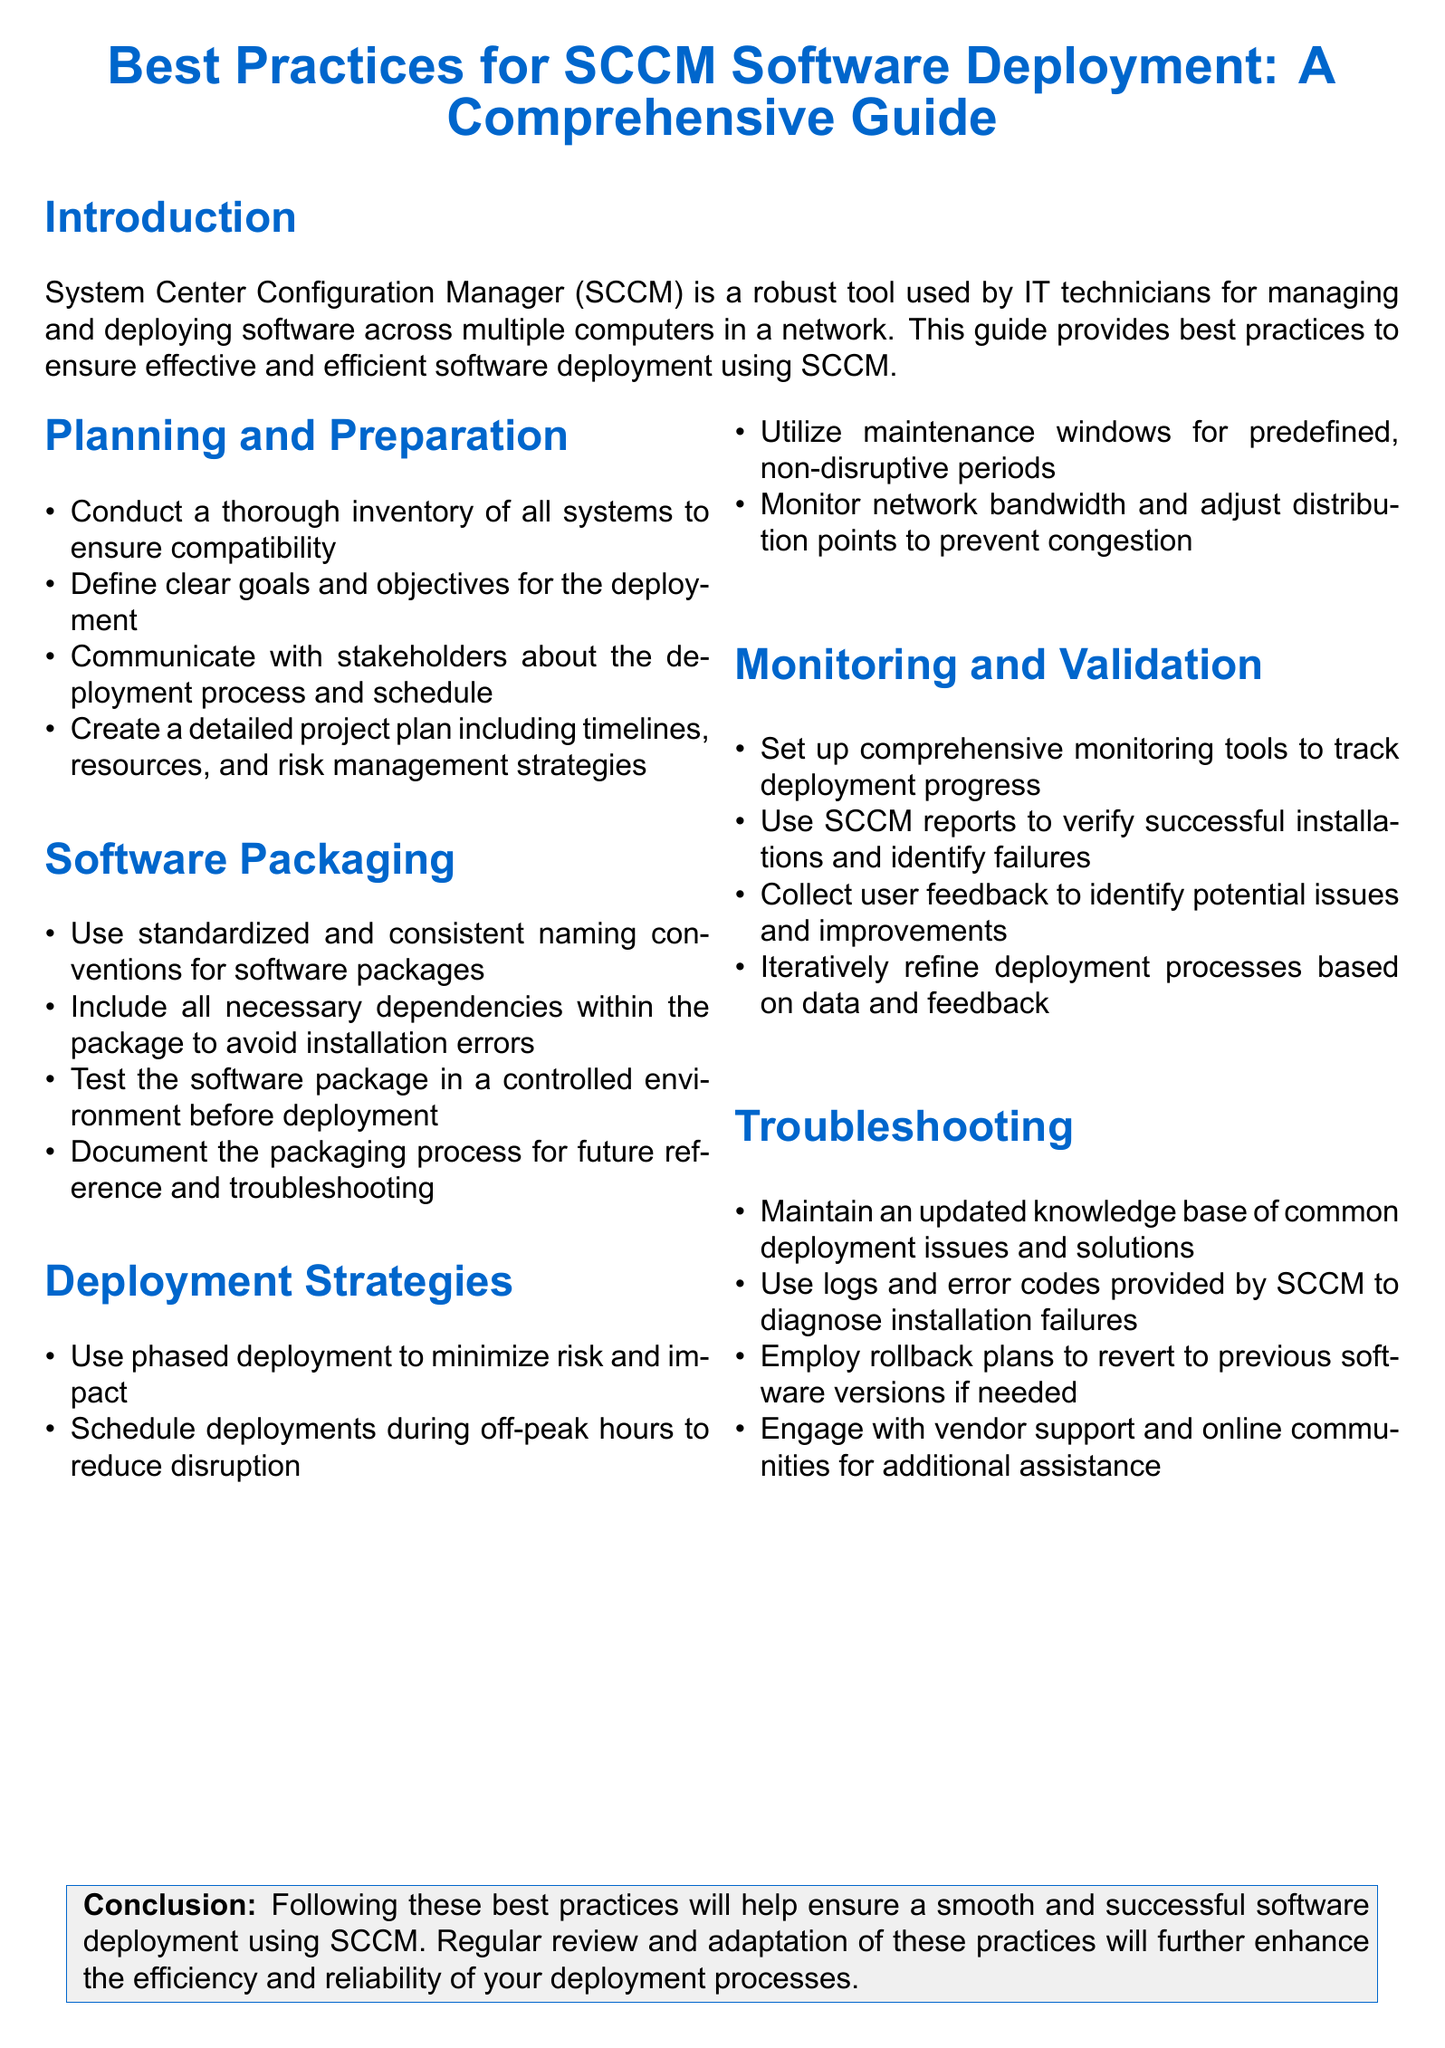What is the primary tool discussed in the document? The document discusses System Center Configuration Manager (SCCM) as the primary tool for software management and deployment.
Answer: System Center Configuration Manager (SCCM) What should be included in a project plan for software deployment? The project plan should include timelines, resources, and risk management strategies as part of its details.
Answer: Timelines, resources, and risk management strategies What is a recommended time for scheduling deployments? The document suggests scheduling deployments during off-peak hours to minimize disruption.
Answer: Off-peak hours How many sections are there in the document? The document has five sections, including Planning and Preparation, Software Packaging, Deployment Strategies, Monitoring and Validation, and Troubleshooting.
Answer: Five What is a benefit of using phased deployment? Phased deployment is recommended to minimize risk and impact during the software deployment process.
Answer: Minimize risk and impact What should be documented during the software packaging process? The packaging process should be documented for future reference and troubleshooting purposes.
Answer: The packaging process What is the purpose of maintenance windows? Maintenance windows are defined as periods for predefined, non-disruptive deployments.
Answer: Non-disruptive periods What tool is advised for tracking deployment progress? The document recommends setting up comprehensive monitoring tools to track deployment progress effectively.
Answer: Comprehensive monitoring tools What should you do if a software installation fails? If a software installation fails, it is advised to use logs and error codes provided by SCCM to diagnose the failure.
Answer: Logs and error codes 